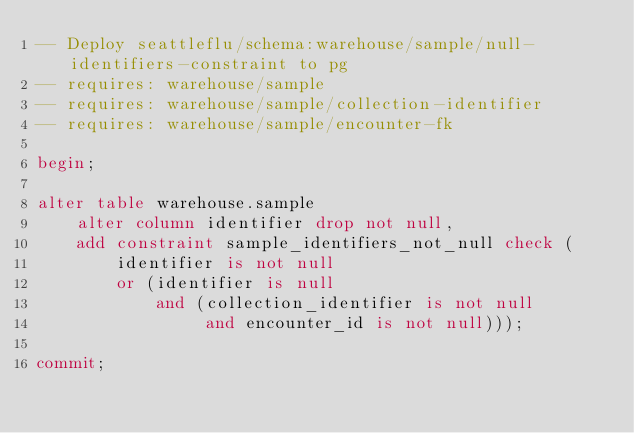Convert code to text. <code><loc_0><loc_0><loc_500><loc_500><_SQL_>-- Deploy seattleflu/schema:warehouse/sample/null-identifiers-constraint to pg
-- requires: warehouse/sample
-- requires: warehouse/sample/collection-identifier
-- requires: warehouse/sample/encounter-fk

begin;

alter table warehouse.sample
    alter column identifier drop not null,
    add constraint sample_identifiers_not_null check (
        identifier is not null
        or (identifier is null
            and (collection_identifier is not null
                 and encounter_id is not null)));

commit;
</code> 